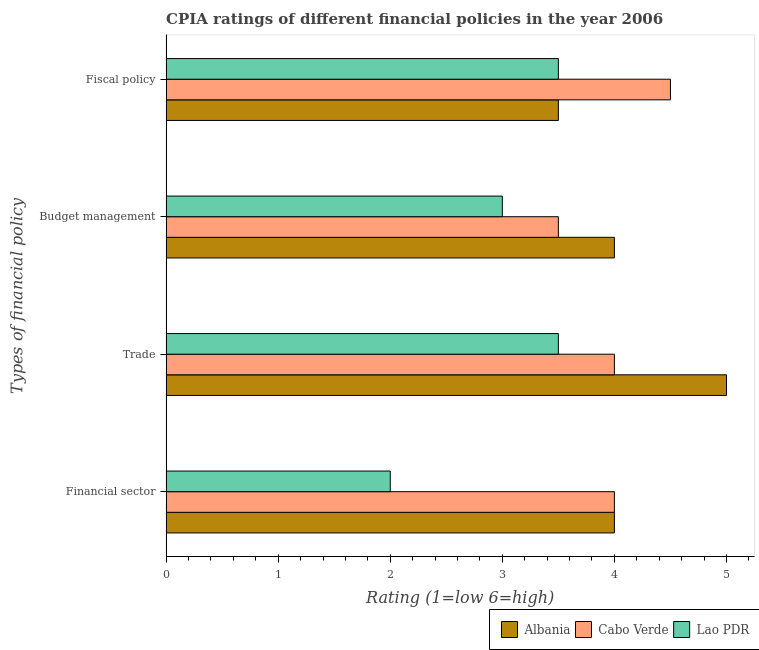How many different coloured bars are there?
Your response must be concise. 3. Are the number of bars per tick equal to the number of legend labels?
Offer a terse response. Yes. Are the number of bars on each tick of the Y-axis equal?
Offer a terse response. Yes. How many bars are there on the 3rd tick from the top?
Keep it short and to the point. 3. How many bars are there on the 1st tick from the bottom?
Make the answer very short. 3. What is the label of the 4th group of bars from the top?
Make the answer very short. Financial sector. Across all countries, what is the maximum cpia rating of financial sector?
Provide a short and direct response. 4. Across all countries, what is the minimum cpia rating of budget management?
Keep it short and to the point. 3. In which country was the cpia rating of financial sector maximum?
Your answer should be very brief. Albania. In which country was the cpia rating of trade minimum?
Your answer should be compact. Lao PDR. What is the difference between the cpia rating of budget management in Albania and that in Lao PDR?
Offer a terse response. 1. What is the difference between the cpia rating of fiscal policy in Cabo Verde and the cpia rating of budget management in Albania?
Make the answer very short. 0.5. What is the average cpia rating of trade per country?
Make the answer very short. 4.17. What is the difference between the cpia rating of financial sector and cpia rating of trade in Lao PDR?
Your response must be concise. -1.5. In how many countries, is the cpia rating of financial sector greater than 3.4 ?
Provide a short and direct response. 2. What is the ratio of the cpia rating of budget management in Cabo Verde to that in Albania?
Provide a short and direct response. 0.88. What is the difference between the highest and the second highest cpia rating of budget management?
Make the answer very short. 0.5. What is the difference between the highest and the lowest cpia rating of fiscal policy?
Your response must be concise. 1. Is the sum of the cpia rating of trade in Albania and Cabo Verde greater than the maximum cpia rating of financial sector across all countries?
Your answer should be very brief. Yes. What does the 2nd bar from the top in Budget management represents?
Give a very brief answer. Cabo Verde. What does the 1st bar from the bottom in Trade represents?
Provide a short and direct response. Albania. Is it the case that in every country, the sum of the cpia rating of financial sector and cpia rating of trade is greater than the cpia rating of budget management?
Your answer should be very brief. Yes. How many bars are there?
Offer a very short reply. 12. How many countries are there in the graph?
Offer a terse response. 3. Are the values on the major ticks of X-axis written in scientific E-notation?
Make the answer very short. No. Where does the legend appear in the graph?
Keep it short and to the point. Bottom right. How are the legend labels stacked?
Make the answer very short. Horizontal. What is the title of the graph?
Your answer should be very brief. CPIA ratings of different financial policies in the year 2006. Does "Jordan" appear as one of the legend labels in the graph?
Keep it short and to the point. No. What is the label or title of the Y-axis?
Offer a terse response. Types of financial policy. What is the Rating (1=low 6=high) in Albania in Financial sector?
Offer a terse response. 4. What is the Rating (1=low 6=high) in Cabo Verde in Financial sector?
Make the answer very short. 4. What is the Rating (1=low 6=high) of Lao PDR in Financial sector?
Ensure brevity in your answer.  2. What is the Rating (1=low 6=high) of Albania in Trade?
Offer a terse response. 5. What is the Rating (1=low 6=high) of Cabo Verde in Budget management?
Offer a terse response. 3.5. What is the Rating (1=low 6=high) of Lao PDR in Budget management?
Make the answer very short. 3. Across all Types of financial policy, what is the maximum Rating (1=low 6=high) in Cabo Verde?
Your answer should be very brief. 4.5. Across all Types of financial policy, what is the maximum Rating (1=low 6=high) in Lao PDR?
Offer a very short reply. 3.5. Across all Types of financial policy, what is the minimum Rating (1=low 6=high) of Albania?
Make the answer very short. 3.5. What is the total Rating (1=low 6=high) of Cabo Verde in the graph?
Your answer should be very brief. 16. What is the difference between the Rating (1=low 6=high) of Albania in Financial sector and that in Trade?
Your answer should be compact. -1. What is the difference between the Rating (1=low 6=high) of Lao PDR in Financial sector and that in Trade?
Provide a short and direct response. -1.5. What is the difference between the Rating (1=low 6=high) of Albania in Financial sector and that in Fiscal policy?
Keep it short and to the point. 0.5. What is the difference between the Rating (1=low 6=high) in Cabo Verde in Financial sector and that in Fiscal policy?
Offer a very short reply. -0.5. What is the difference between the Rating (1=low 6=high) of Lao PDR in Financial sector and that in Fiscal policy?
Provide a succinct answer. -1.5. What is the difference between the Rating (1=low 6=high) of Albania in Trade and that in Fiscal policy?
Ensure brevity in your answer.  1.5. What is the difference between the Rating (1=low 6=high) in Cabo Verde in Trade and that in Fiscal policy?
Give a very brief answer. -0.5. What is the difference between the Rating (1=low 6=high) in Albania in Budget management and that in Fiscal policy?
Keep it short and to the point. 0.5. What is the difference between the Rating (1=low 6=high) in Albania in Financial sector and the Rating (1=low 6=high) in Lao PDR in Trade?
Ensure brevity in your answer.  0.5. What is the difference between the Rating (1=low 6=high) of Cabo Verde in Financial sector and the Rating (1=low 6=high) of Lao PDR in Trade?
Your answer should be very brief. 0.5. What is the difference between the Rating (1=low 6=high) in Albania in Financial sector and the Rating (1=low 6=high) in Cabo Verde in Budget management?
Offer a terse response. 0.5. What is the difference between the Rating (1=low 6=high) in Albania in Financial sector and the Rating (1=low 6=high) in Lao PDR in Budget management?
Your response must be concise. 1. What is the difference between the Rating (1=low 6=high) in Cabo Verde in Financial sector and the Rating (1=low 6=high) in Lao PDR in Fiscal policy?
Give a very brief answer. 0.5. What is the difference between the Rating (1=low 6=high) of Albania in Trade and the Rating (1=low 6=high) of Lao PDR in Budget management?
Your answer should be very brief. 2. What is the difference between the Rating (1=low 6=high) in Cabo Verde in Trade and the Rating (1=low 6=high) in Lao PDR in Budget management?
Keep it short and to the point. 1. What is the difference between the Rating (1=low 6=high) in Cabo Verde in Trade and the Rating (1=low 6=high) in Lao PDR in Fiscal policy?
Your answer should be very brief. 0.5. What is the difference between the Rating (1=low 6=high) in Albania in Budget management and the Rating (1=low 6=high) in Cabo Verde in Fiscal policy?
Offer a very short reply. -0.5. What is the difference between the Rating (1=low 6=high) of Cabo Verde in Budget management and the Rating (1=low 6=high) of Lao PDR in Fiscal policy?
Offer a terse response. 0. What is the average Rating (1=low 6=high) of Albania per Types of financial policy?
Ensure brevity in your answer.  4.12. What is the average Rating (1=low 6=high) of Cabo Verde per Types of financial policy?
Keep it short and to the point. 4. What is the average Rating (1=low 6=high) in Lao PDR per Types of financial policy?
Provide a short and direct response. 3. What is the difference between the Rating (1=low 6=high) of Cabo Verde and Rating (1=low 6=high) of Lao PDR in Financial sector?
Give a very brief answer. 2. What is the difference between the Rating (1=low 6=high) in Cabo Verde and Rating (1=low 6=high) in Lao PDR in Trade?
Your answer should be compact. 0.5. What is the difference between the Rating (1=low 6=high) in Cabo Verde and Rating (1=low 6=high) in Lao PDR in Budget management?
Provide a short and direct response. 0.5. What is the difference between the Rating (1=low 6=high) in Albania and Rating (1=low 6=high) in Lao PDR in Fiscal policy?
Make the answer very short. 0. What is the difference between the Rating (1=low 6=high) in Cabo Verde and Rating (1=low 6=high) in Lao PDR in Fiscal policy?
Ensure brevity in your answer.  1. What is the ratio of the Rating (1=low 6=high) of Albania in Financial sector to that in Trade?
Your answer should be compact. 0.8. What is the ratio of the Rating (1=low 6=high) of Albania in Financial sector to that in Budget management?
Provide a succinct answer. 1. What is the ratio of the Rating (1=low 6=high) of Albania in Financial sector to that in Fiscal policy?
Your response must be concise. 1.14. What is the ratio of the Rating (1=low 6=high) of Lao PDR in Financial sector to that in Fiscal policy?
Make the answer very short. 0.57. What is the ratio of the Rating (1=low 6=high) in Cabo Verde in Trade to that in Budget management?
Your answer should be very brief. 1.14. What is the ratio of the Rating (1=low 6=high) in Albania in Trade to that in Fiscal policy?
Give a very brief answer. 1.43. What is the ratio of the Rating (1=low 6=high) of Lao PDR in Trade to that in Fiscal policy?
Your answer should be very brief. 1. What is the ratio of the Rating (1=low 6=high) in Cabo Verde in Budget management to that in Fiscal policy?
Your answer should be compact. 0.78. What is the ratio of the Rating (1=low 6=high) in Lao PDR in Budget management to that in Fiscal policy?
Your answer should be compact. 0.86. What is the difference between the highest and the second highest Rating (1=low 6=high) of Albania?
Make the answer very short. 1. What is the difference between the highest and the second highest Rating (1=low 6=high) in Cabo Verde?
Your answer should be compact. 0.5. What is the difference between the highest and the second highest Rating (1=low 6=high) in Lao PDR?
Your answer should be compact. 0. What is the difference between the highest and the lowest Rating (1=low 6=high) of Albania?
Offer a very short reply. 1.5. What is the difference between the highest and the lowest Rating (1=low 6=high) in Cabo Verde?
Your response must be concise. 1. 